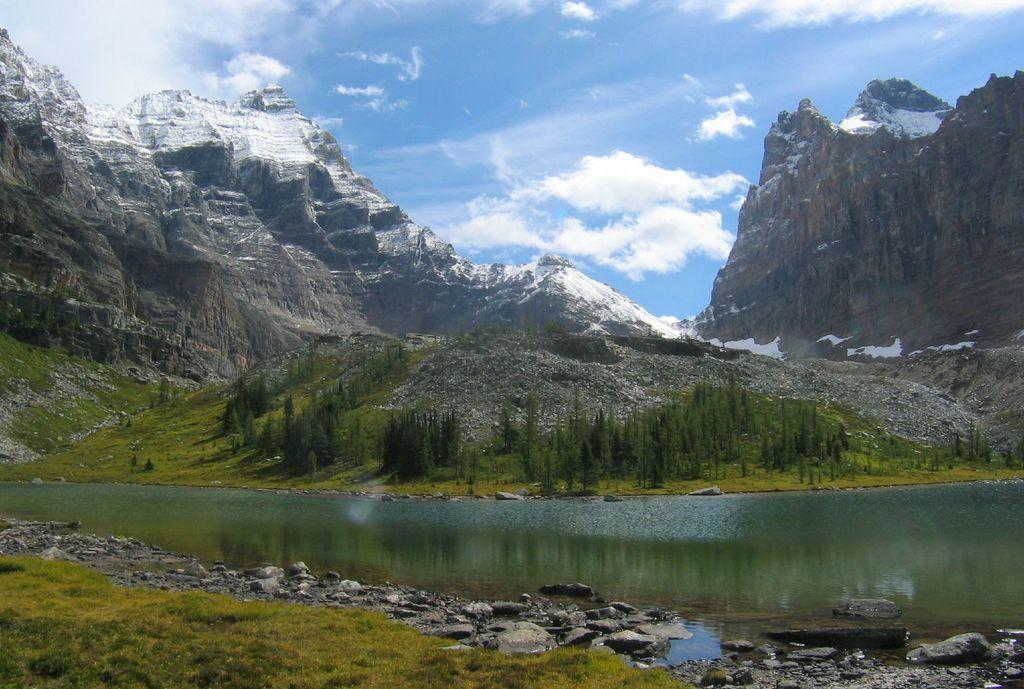What type of natural features can be seen in the image? There are trees, mountains, and water visible in the image. Can you describe the water in the image? The water is visible at the bottom of the image, and there are rocks in the water. What is visible in the sky at the top of the image? There are clouds in the sky at the top of the image. What type of meat is being suggested in the image? There is no meat present in the image, nor is any suggestion being made. 